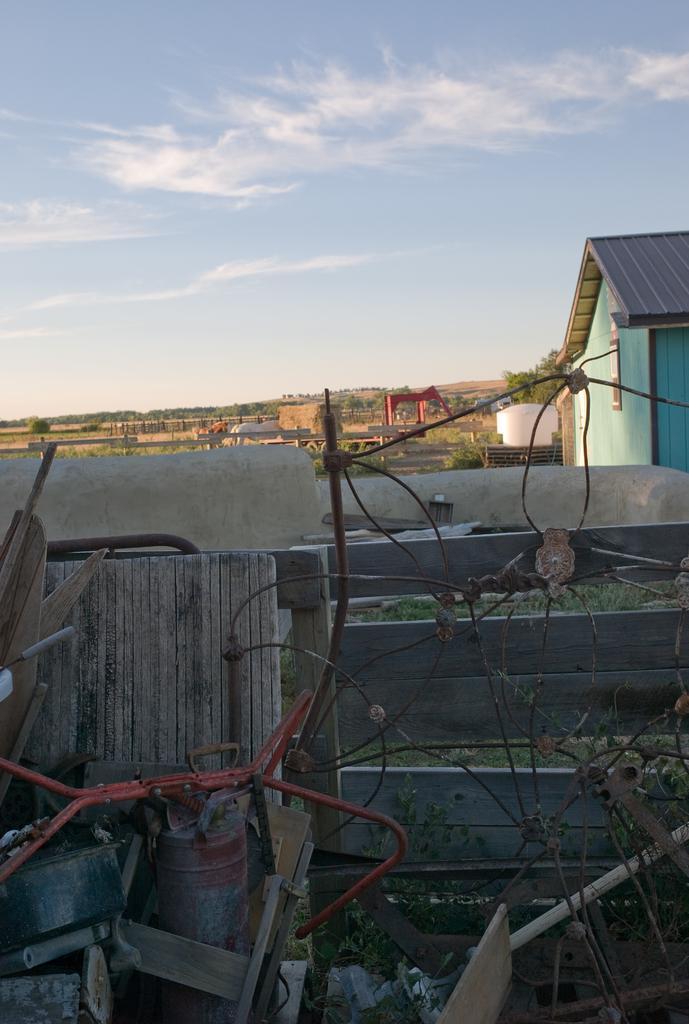Please provide a concise description of this image. In this image we can see an iron wire, few wooden objects, wooden fence, beside there is a house, grass, trees, hills, we can see the sky with clouds. 